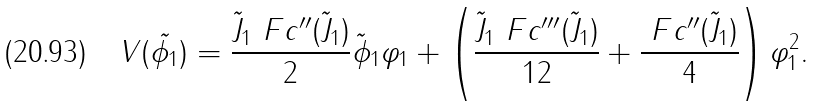Convert formula to latex. <formula><loc_0><loc_0><loc_500><loc_500>V ( \tilde { \phi _ { 1 } } ) = \frac { \tilde { J } _ { 1 } \ F c ^ { \prime \prime } ( \tilde { J } _ { 1 } ) } { 2 } \tilde { \phi } _ { 1 } \varphi _ { 1 } + \left ( \frac { { \tilde { J } _ { 1 } \ F c ^ { \prime \prime \prime } ( \tilde { J } _ { 1 } ) } } { 1 2 } + \frac { { \ F c ^ { \prime \prime } ( \tilde { J } _ { 1 } ) } } { 4 } \right ) \varphi _ { 1 } ^ { 2 } .</formula> 